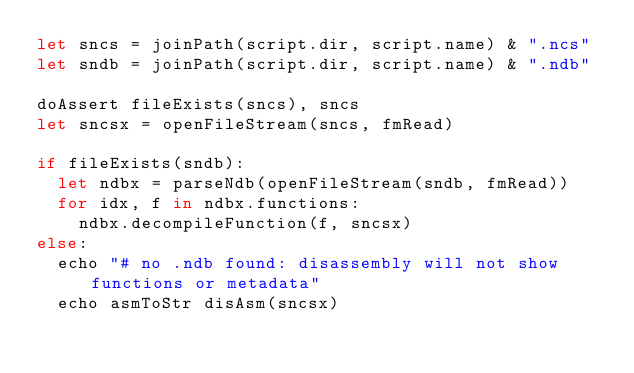<code> <loc_0><loc_0><loc_500><loc_500><_Nim_>let sncs = joinPath(script.dir, script.name) & ".ncs"
let sndb = joinPath(script.dir, script.name) & ".ndb"

doAssert fileExists(sncs), sncs
let sncsx = openFileStream(sncs, fmRead)

if fileExists(sndb):
  let ndbx = parseNdb(openFileStream(sndb, fmRead))
  for idx, f in ndbx.functions:
    ndbx.decompileFunction(f, sncsx)
else:
  echo "# no .ndb found: disassembly will not show functions or metadata"
  echo asmToStr disAsm(sncsx)
</code> 